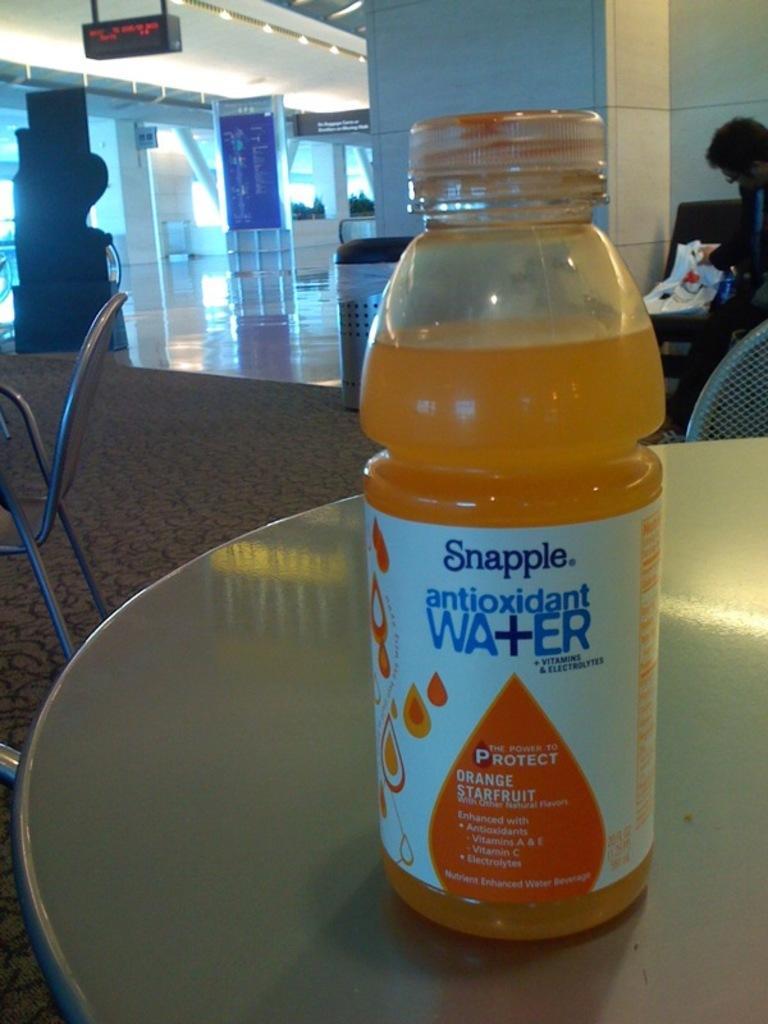Can you describe this image briefly? In this image I see a bottle on the table and I see a chair over here. In the background I see the wall, board and a person over here. 